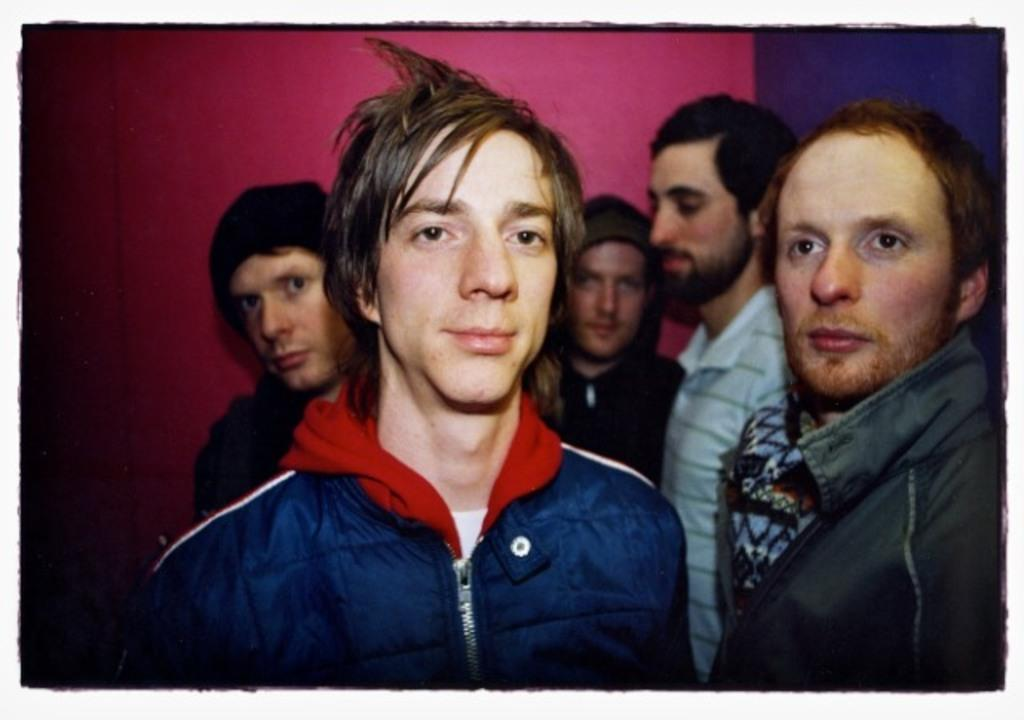What can be seen in the image? There is a group of men in the image. What are some of the men wearing? Some of the men are wearing jackets. Can you describe the quality of the image? The image is slightly blurry. What type of skin is visible on the men in the image? There is no specific type of skin mentioned or visible in the image. What is the profit margin for the men in the image? There is no information about profit margins in the image. 